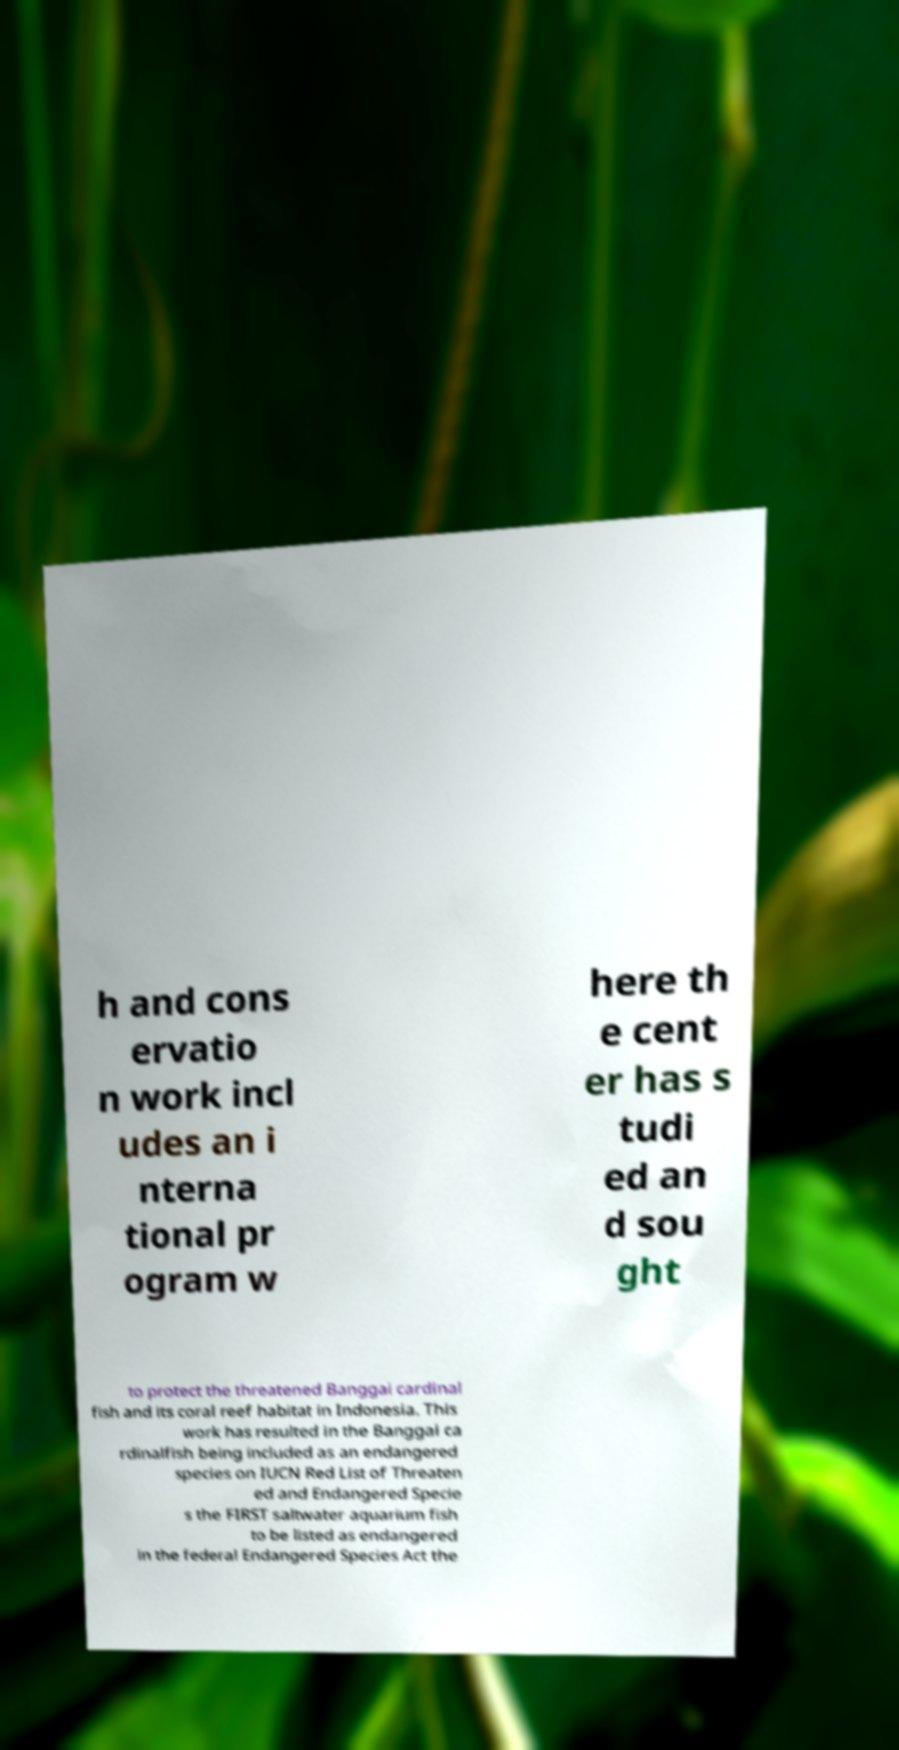What messages or text are displayed in this image? I need them in a readable, typed format. h and cons ervatio n work incl udes an i nterna tional pr ogram w here th e cent er has s tudi ed an d sou ght to protect the threatened Banggai cardinal fish and its coral reef habitat in Indonesia. This work has resulted in the Banggai ca rdinalfish being included as an endangered species on IUCN Red List of Threaten ed and Endangered Specie s the FIRST saltwater aquarium fish to be listed as endangered in the federal Endangered Species Act the 